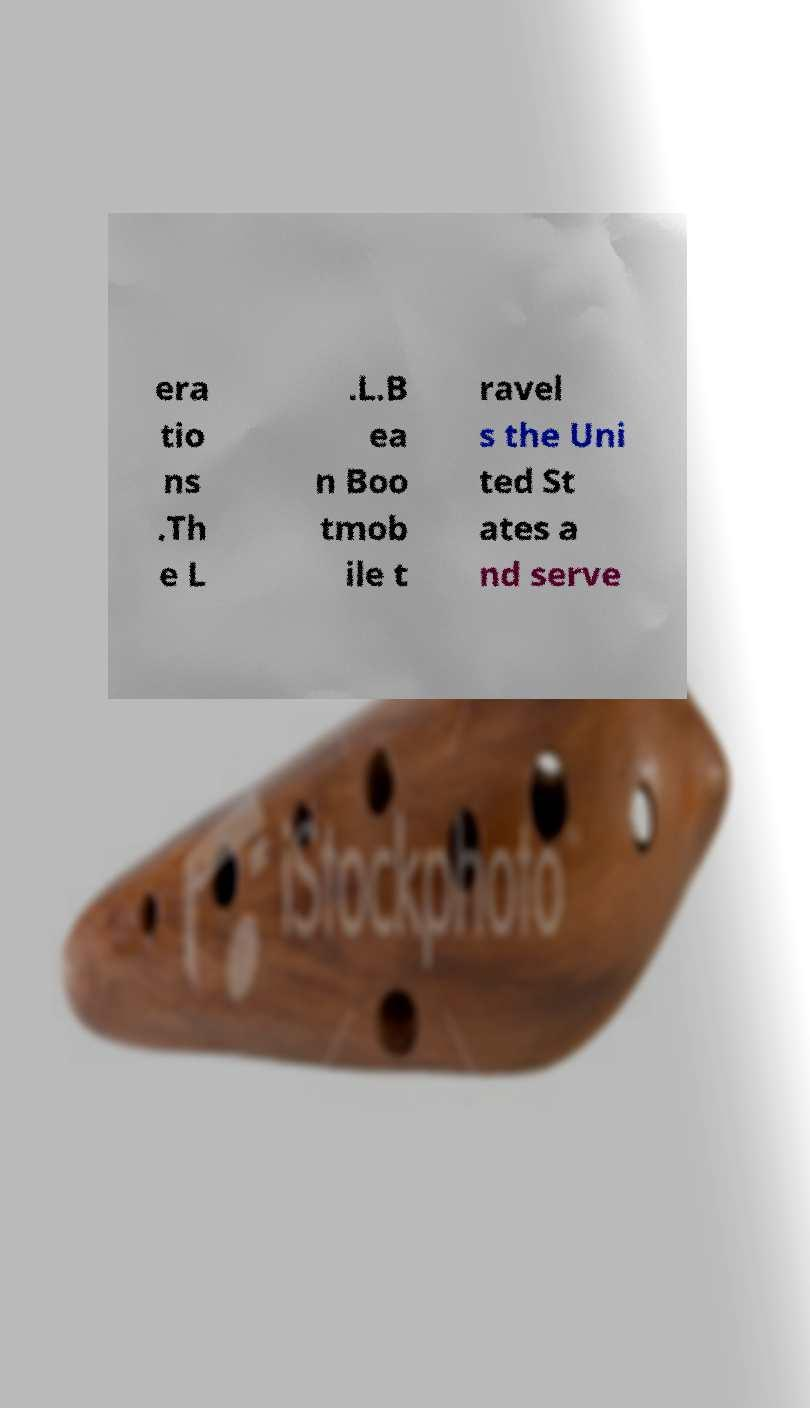For documentation purposes, I need the text within this image transcribed. Could you provide that? era tio ns .Th e L .L.B ea n Boo tmob ile t ravel s the Uni ted St ates a nd serve 